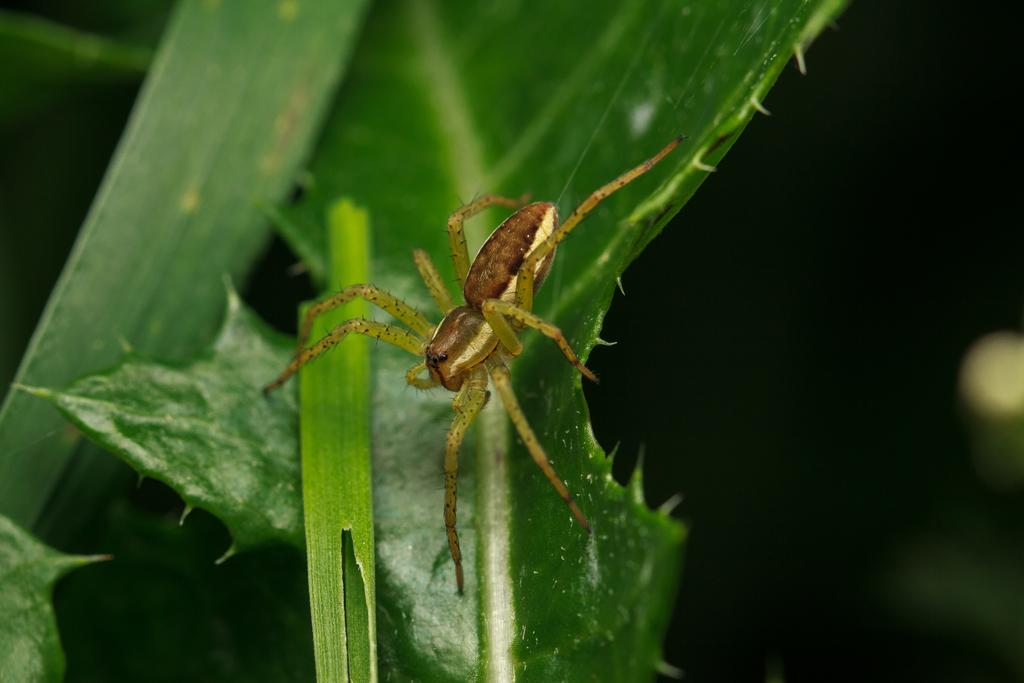What type of spider is in the image? There is a wolf spider in the image. Where is the wolf spider located? The wolf spider is on a leaf. What type of sand can be seen in the image? There is no sand present in the image; it features a wolf spider on a leaf. What agreement was reached between the wolf spider and the leaf in the image? There is no indication of any agreement between the wolf spider and the leaf in the image. 